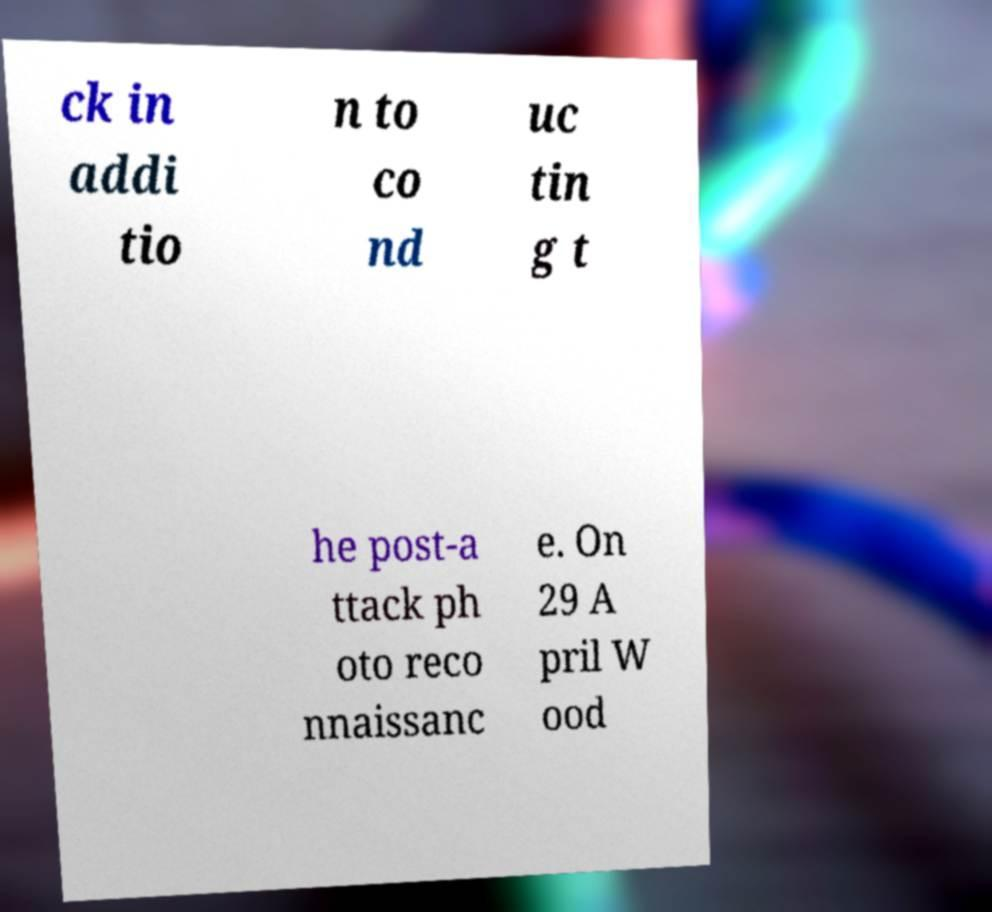Could you assist in decoding the text presented in this image and type it out clearly? ck in addi tio n to co nd uc tin g t he post-a ttack ph oto reco nnaissanc e. On 29 A pril W ood 